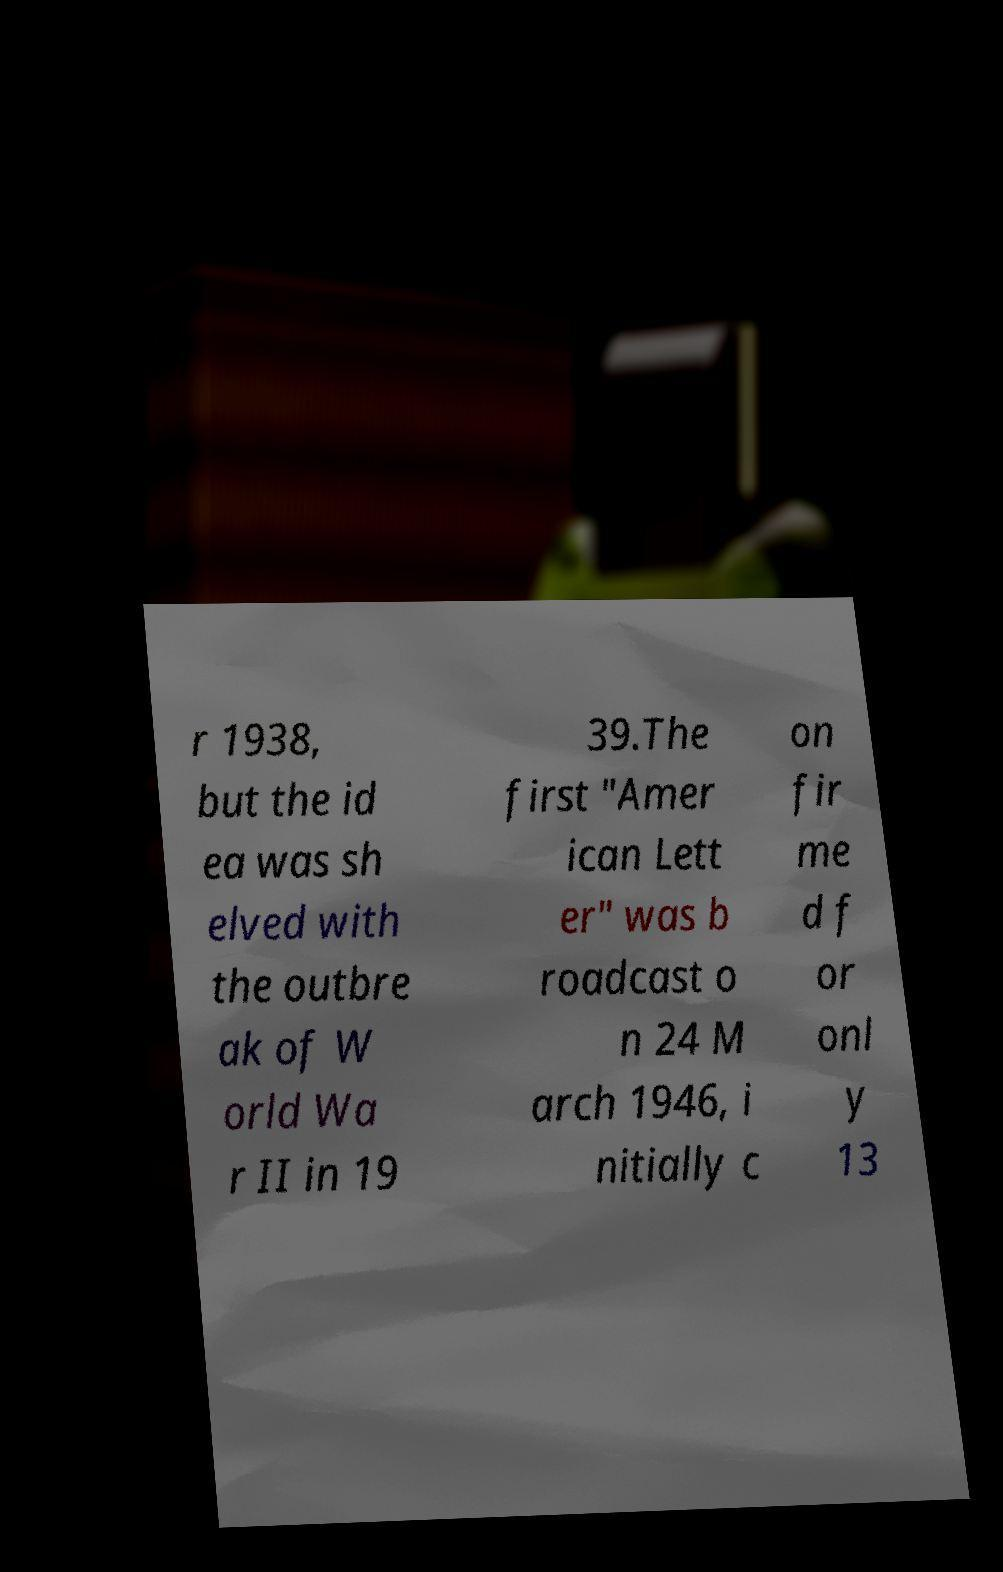What messages or text are displayed in this image? I need them in a readable, typed format. r 1938, but the id ea was sh elved with the outbre ak of W orld Wa r II in 19 39.The first "Amer ican Lett er" was b roadcast o n 24 M arch 1946, i nitially c on fir me d f or onl y 13 